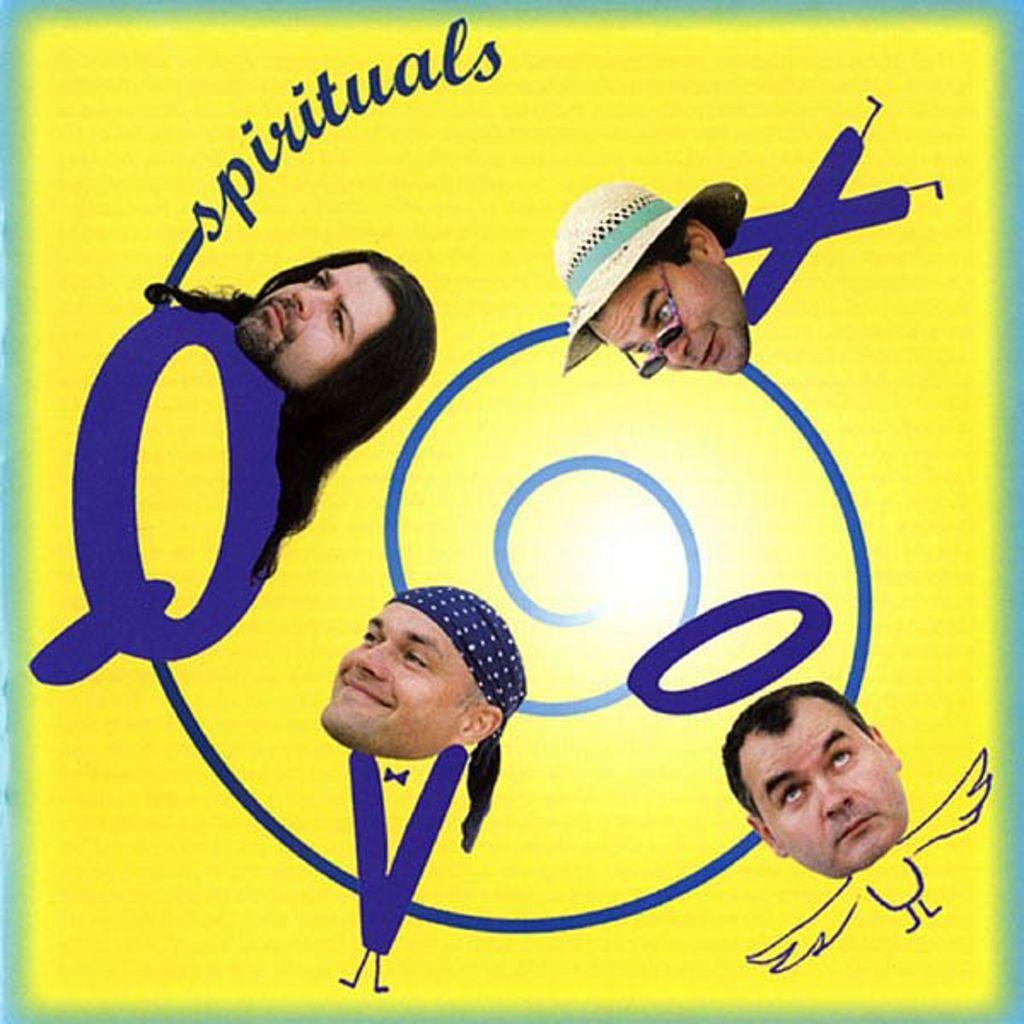How many people's heads are visible in the image? There are four persons' heads in the image. What color is the text in the image? The text in the image is blue. What color is the background of the image? The background of the image is yellow. What type of board can be seen in the image? There is no board present in the image. What scene is depicted in the image? The image only shows four persons' heads, text, and a yellow background, so it does not depict a specific scene. 